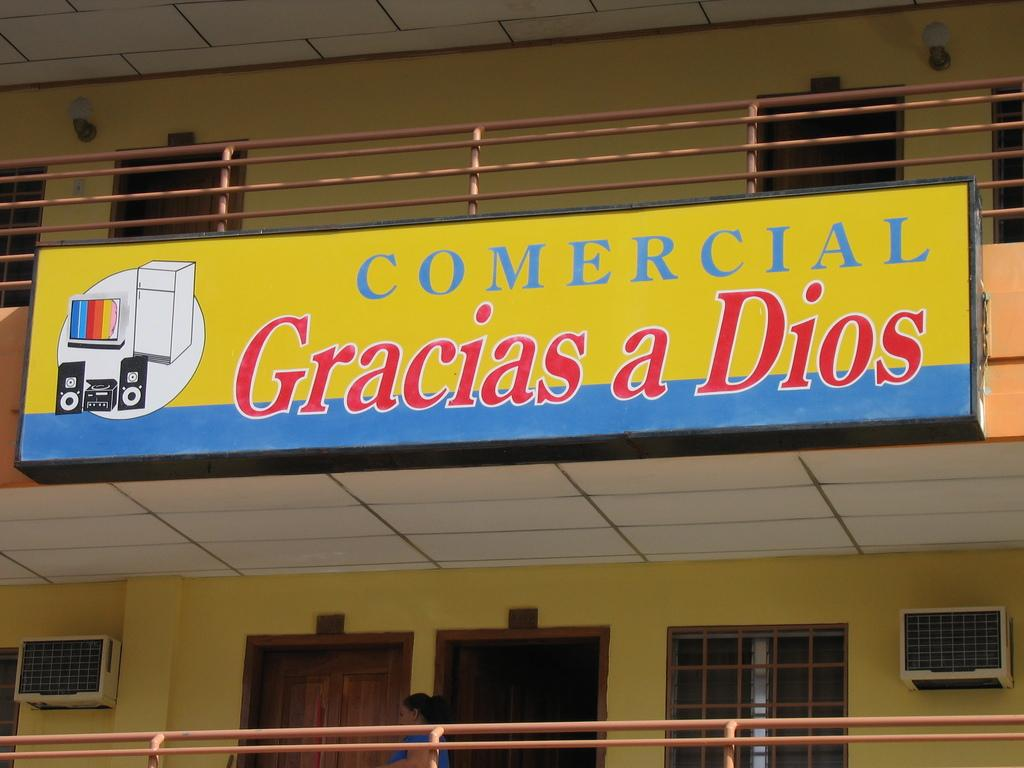What type of structure is visible in the image? There is a building in the image. What feature can be seen on the building? The building has railing. What are some ways to enter or exit the building? There are doors in the building. How can natural light enter the building? There are windows in the building. What is located near the building? There is a huge board near the building. What colors are present on the board? The board has yellow, blue, black, red, and white colors. How many cars are parked in front of the building in the image? There is no information about cars in the image; it only mentions the building, its features, and the huge board near it. 